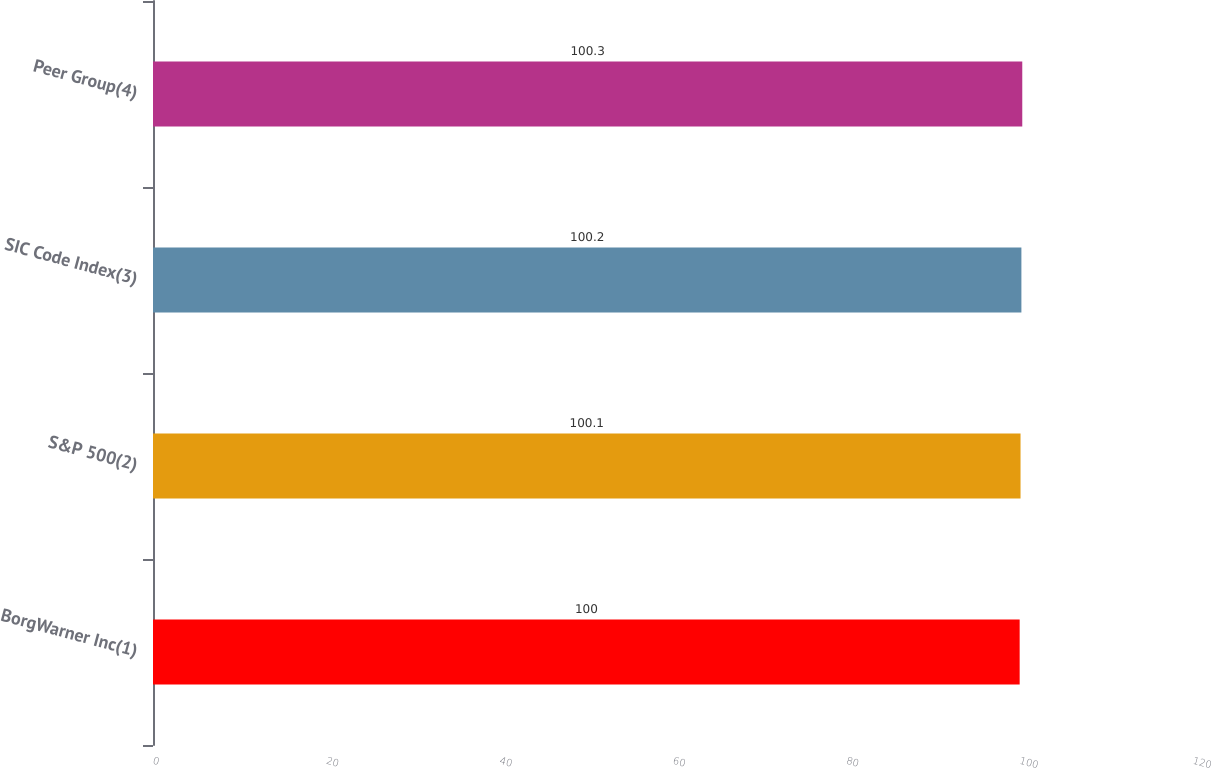Convert chart. <chart><loc_0><loc_0><loc_500><loc_500><bar_chart><fcel>BorgWarner Inc(1)<fcel>S&P 500(2)<fcel>SIC Code Index(3)<fcel>Peer Group(4)<nl><fcel>100<fcel>100.1<fcel>100.2<fcel>100.3<nl></chart> 